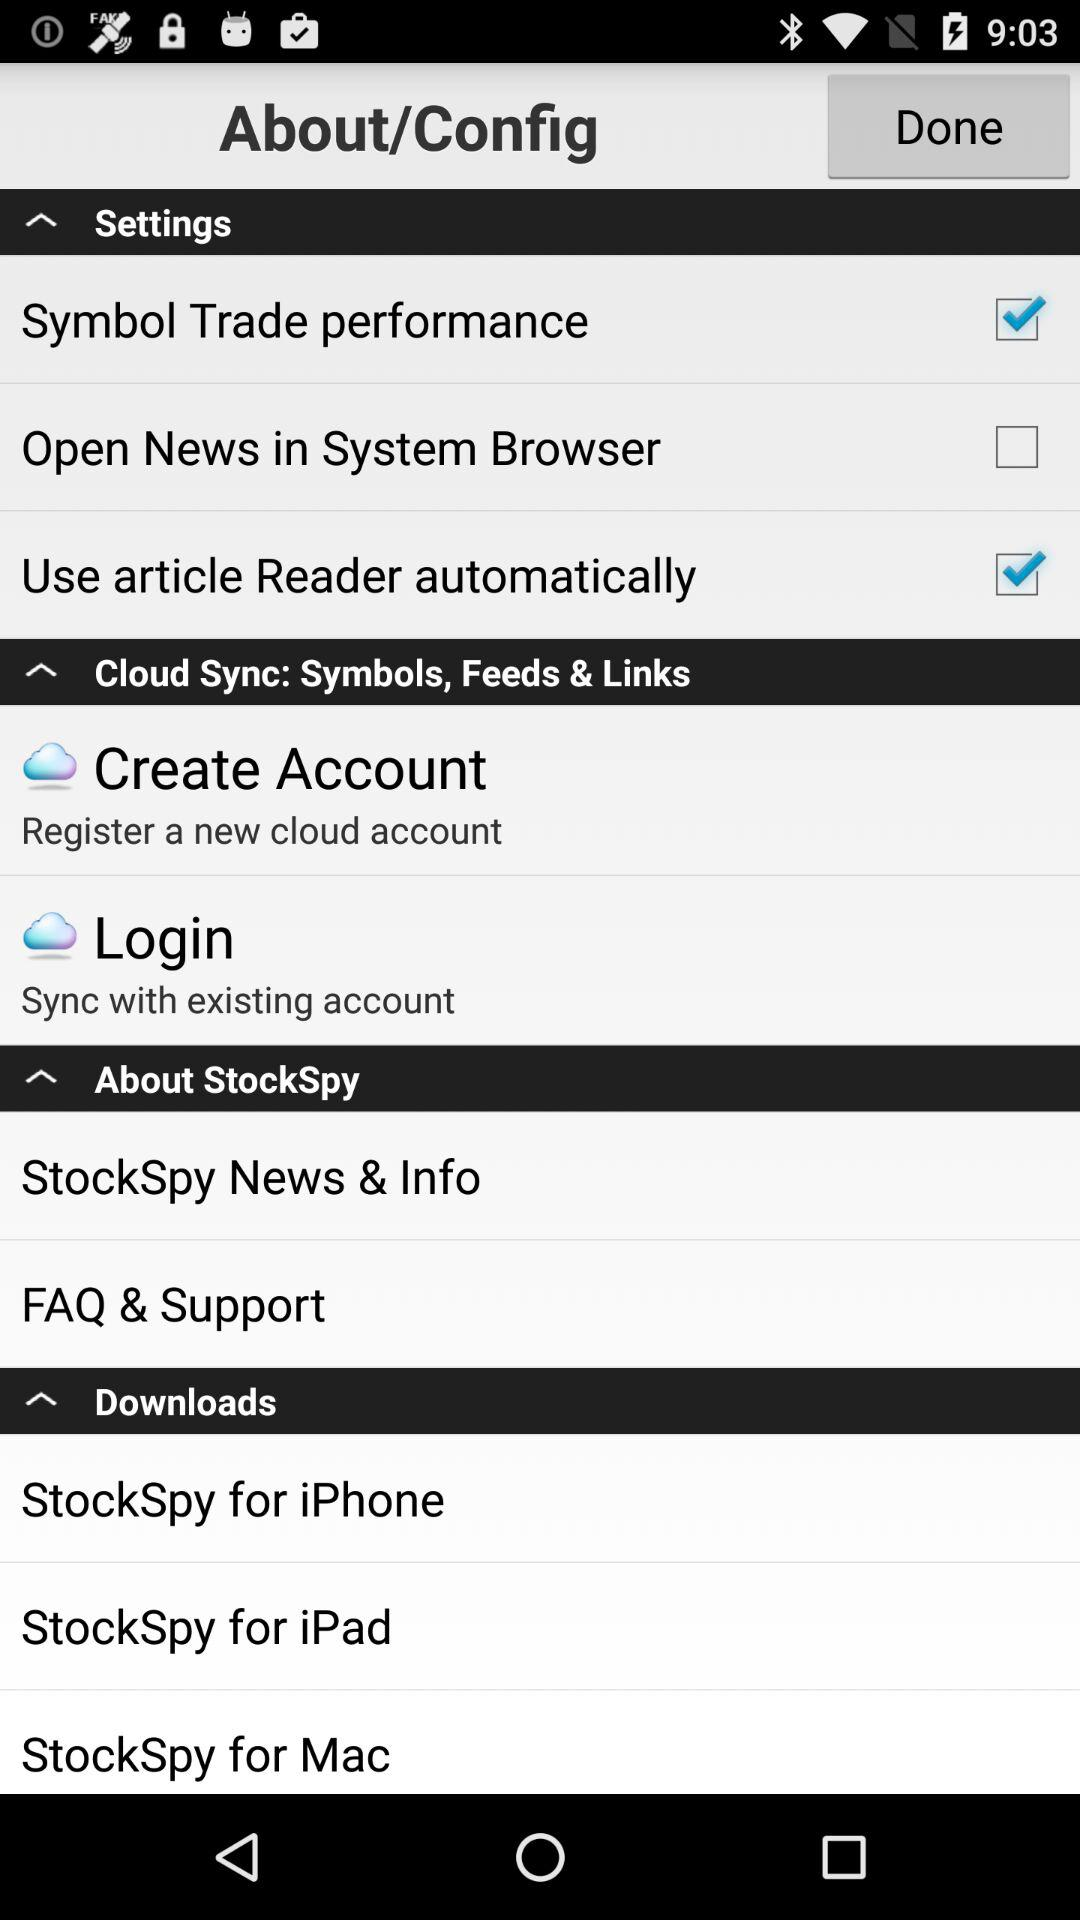How many checkboxes are in the Settings section?
Answer the question using a single word or phrase. 3 